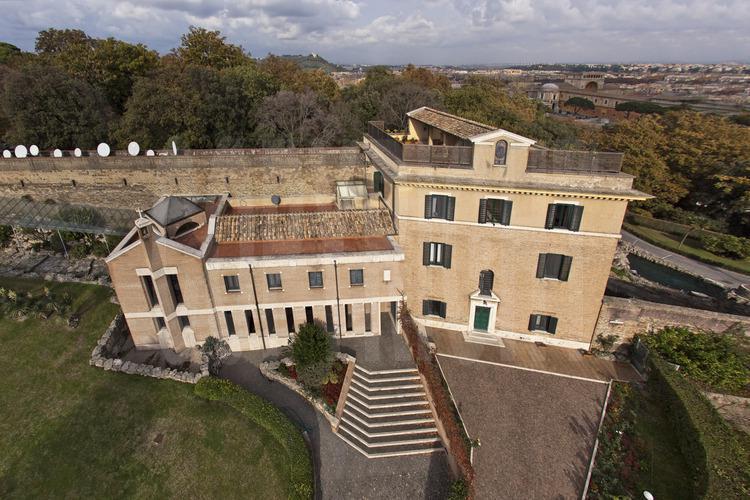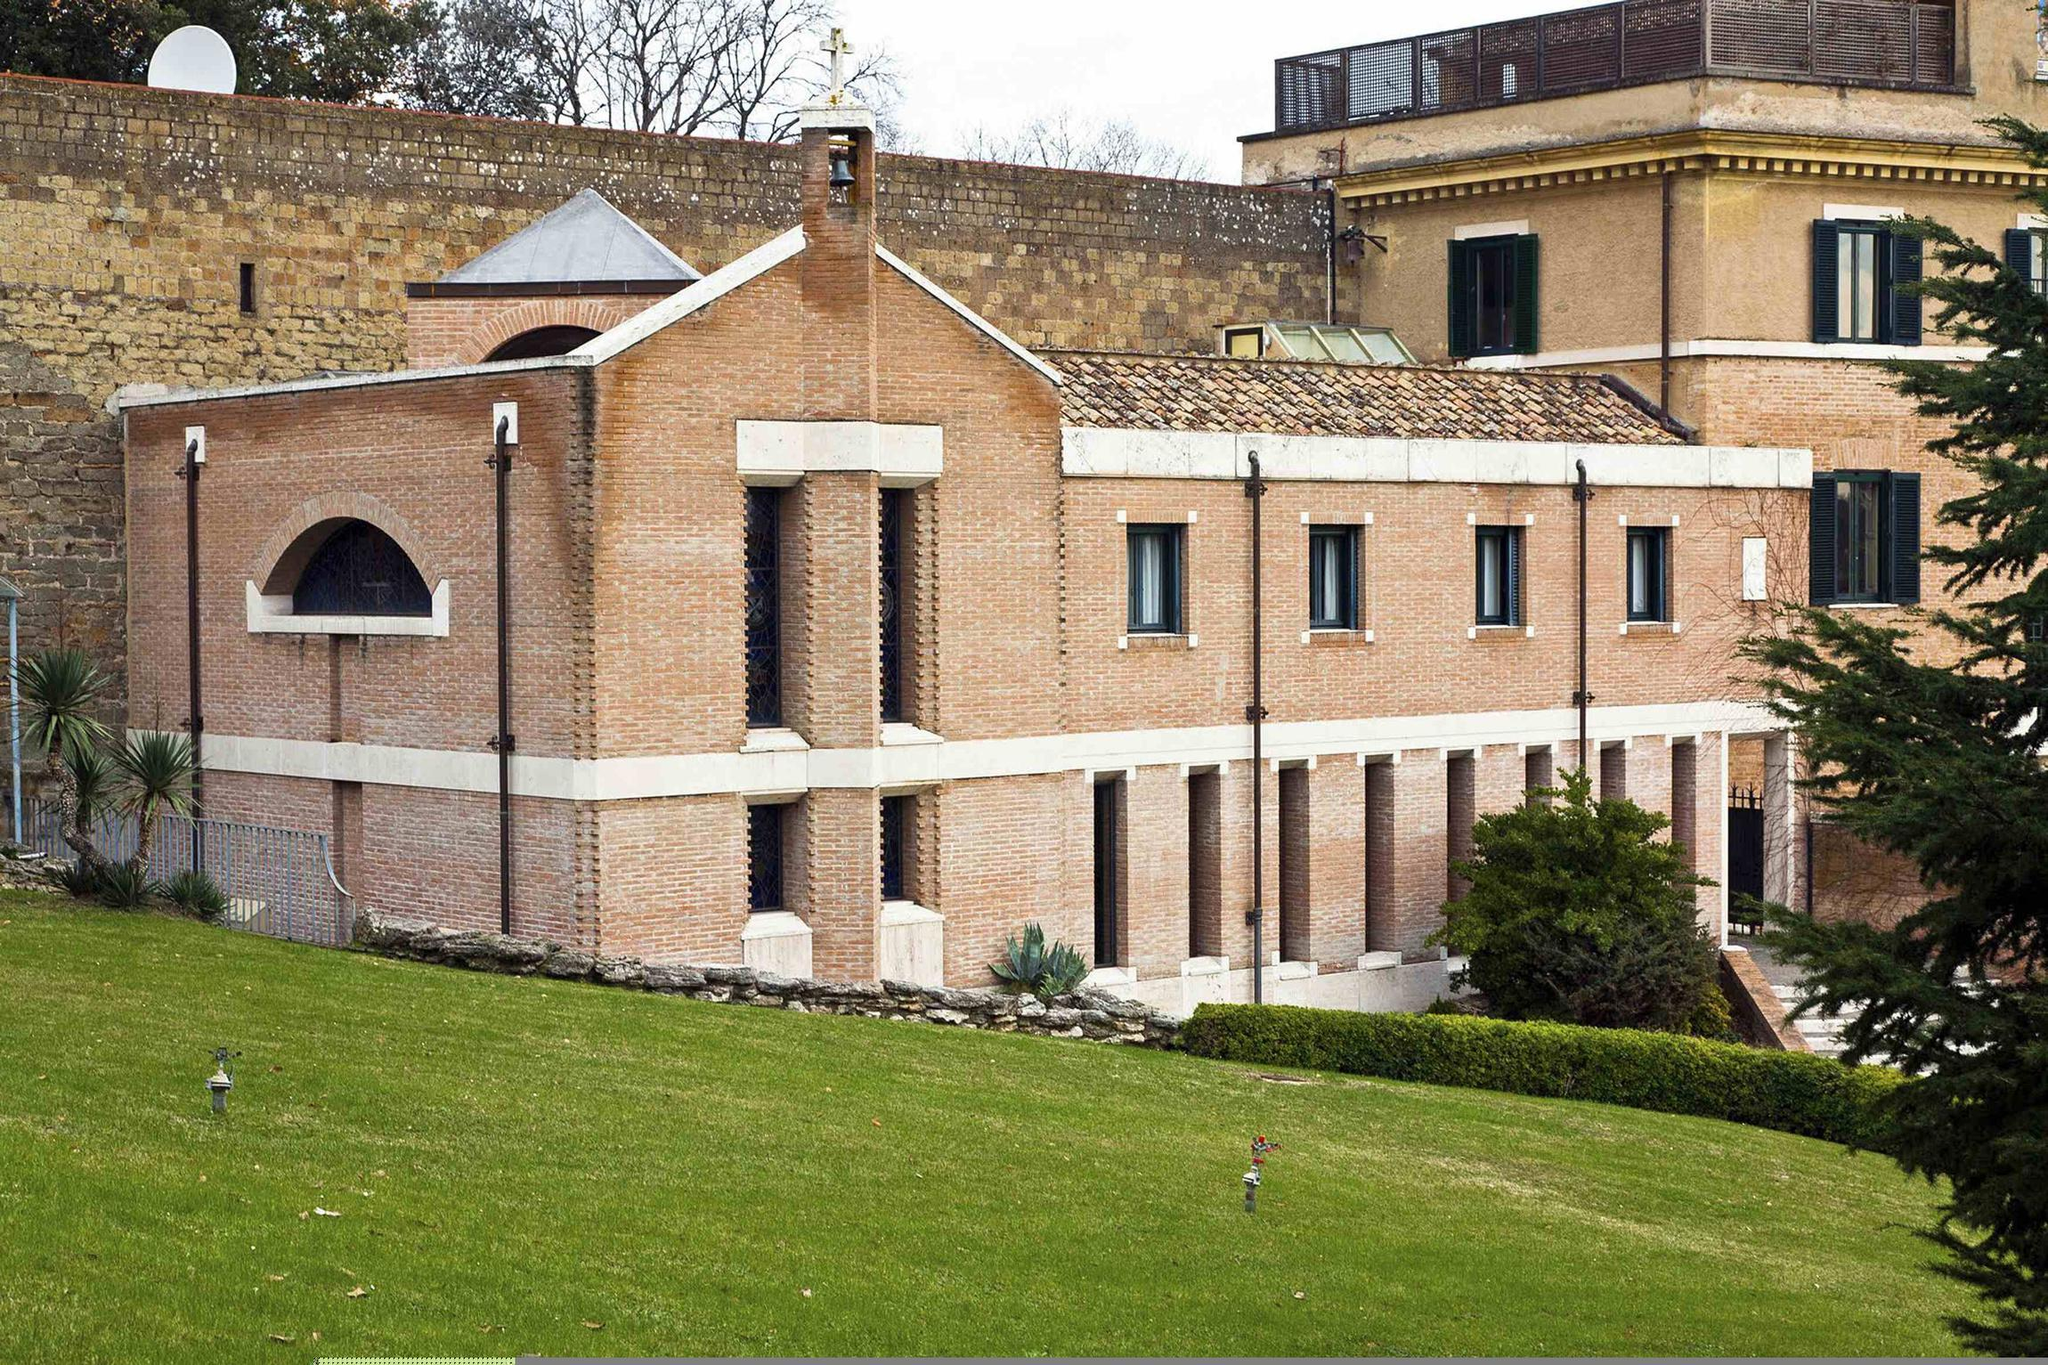The first image is the image on the left, the second image is the image on the right. Given the left and right images, does the statement "There are stairs in the image on the left." hold true? Answer yes or no. Yes. 